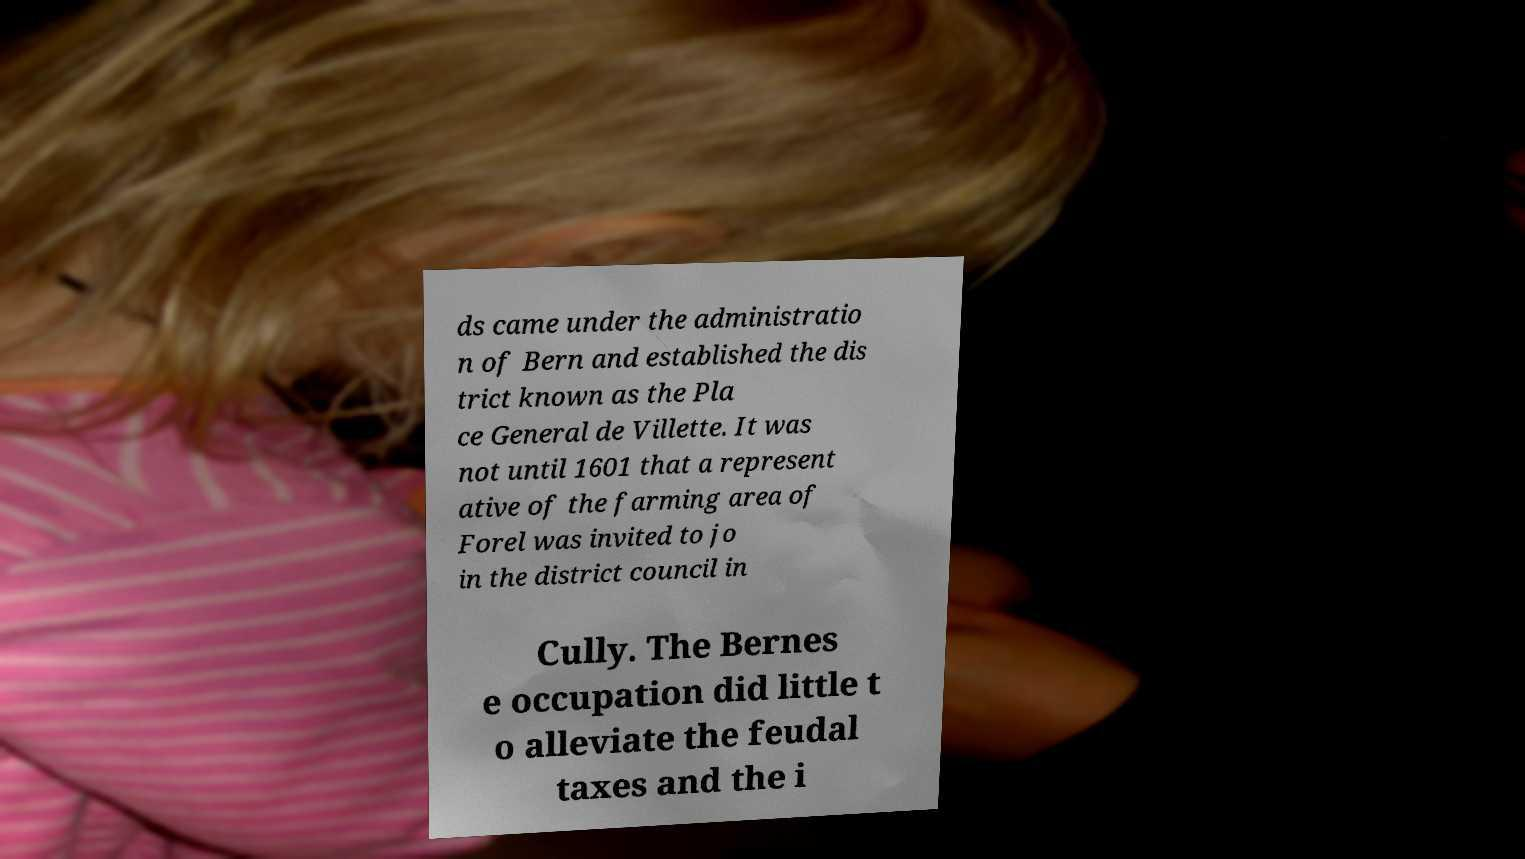Could you extract and type out the text from this image? ds came under the administratio n of Bern and established the dis trict known as the Pla ce General de Villette. It was not until 1601 that a represent ative of the farming area of Forel was invited to jo in the district council in Cully. The Bernes e occupation did little t o alleviate the feudal taxes and the i 